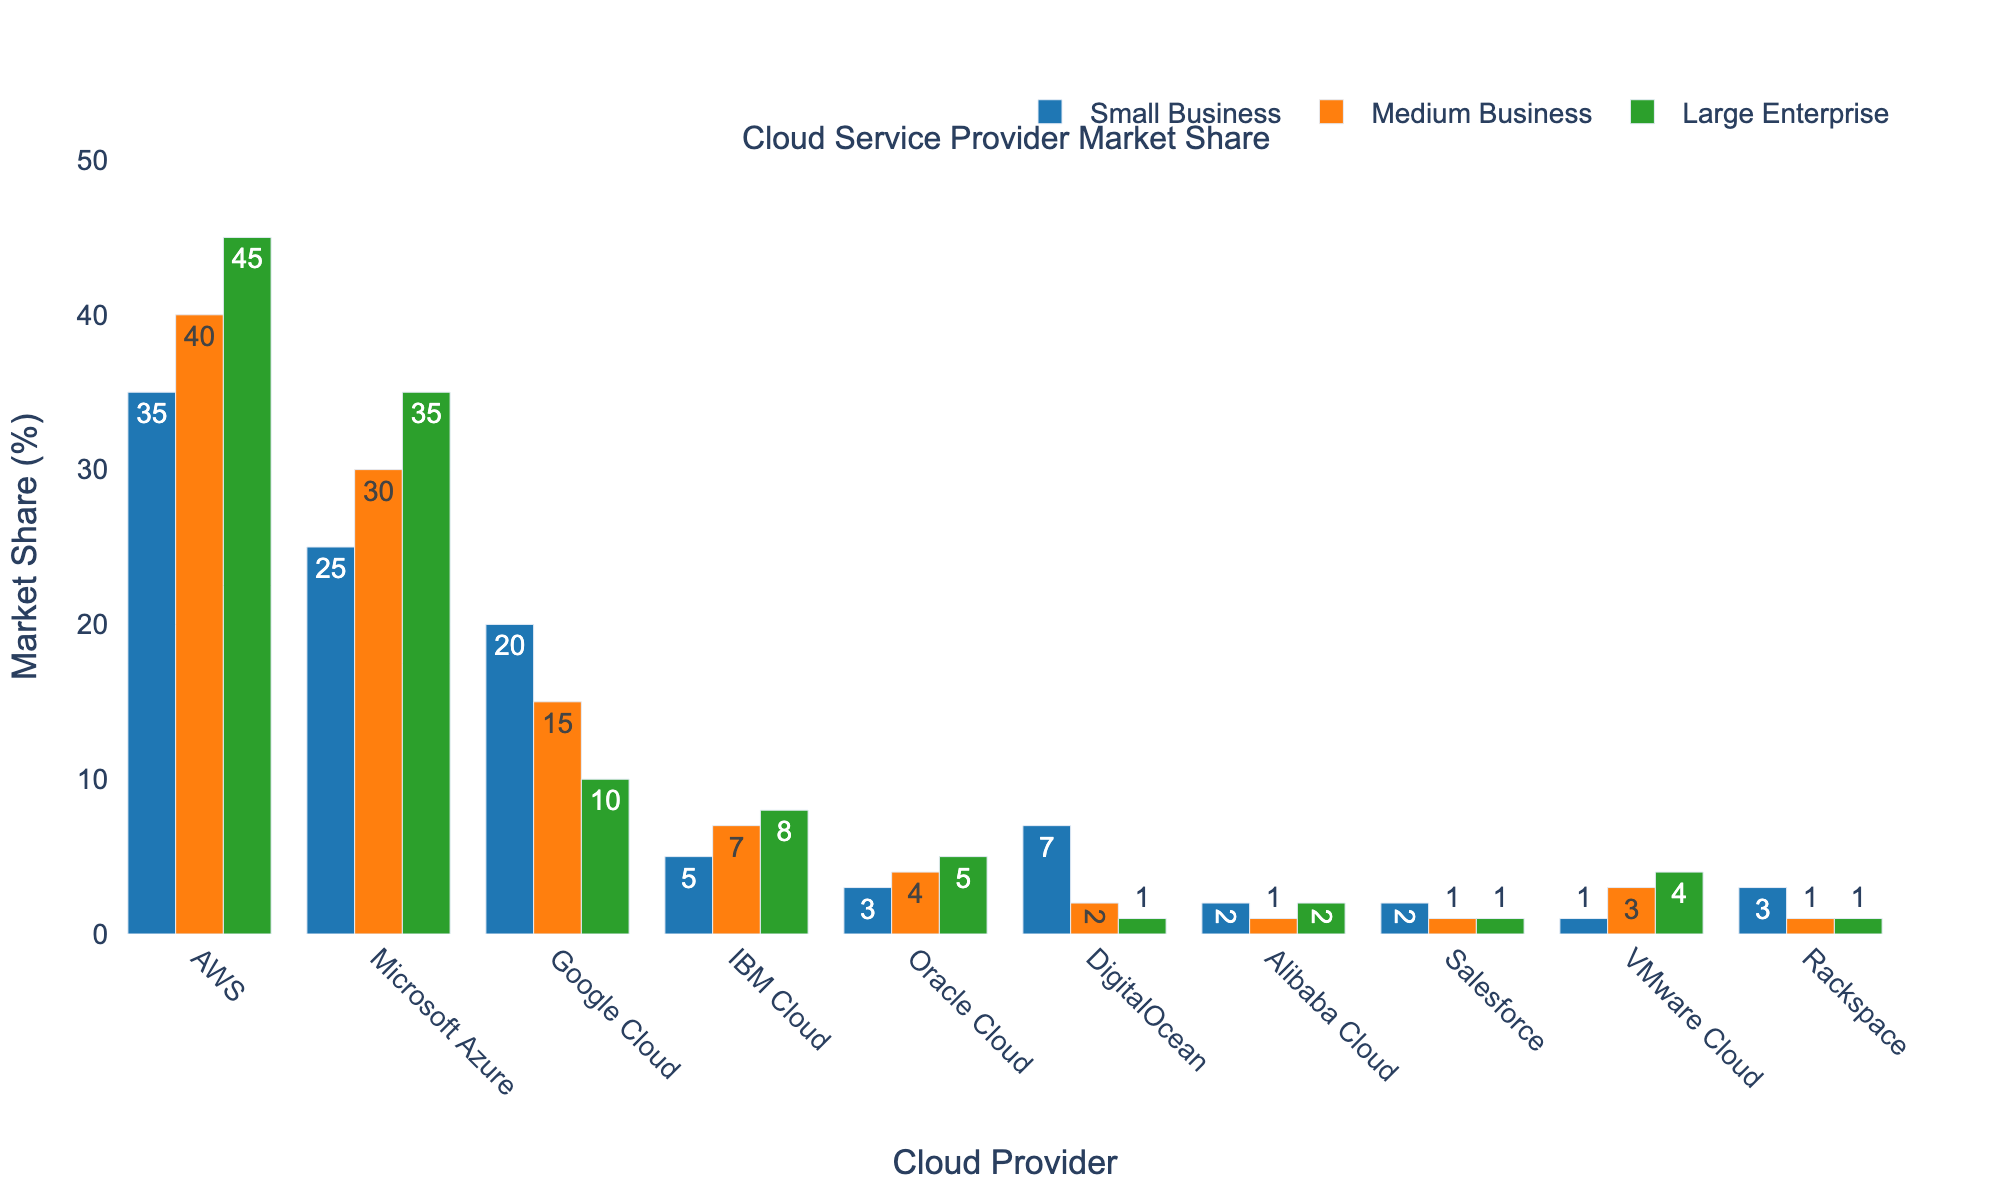Which cloud provider has the highest market share among medium businesses? Look at the Medium Business bars and see which one is the tallest. AWS has a market share of 40%, which is the highest among medium businesses.
Answer: AWS What is the total market share for IBM Cloud across all company sizes? Sum the market shares of IBM Cloud for Small Business, Medium Business, and Large Enterprise. IBM Cloud has 5% (Small Business) + 7% (Medium Business) + 8% (Large Enterprise) = 20%.
Answer: 20% Which company has the smallest market share for large enterprises? Examine the Large Enterprise bars to find the shortest one. Salesforce has the smallest market share at 1%.
Answer: Salesforce How much higher is AWS's market share in large enterprises compared to Google Cloud? Compare the market share percentages for AWS and Google Cloud in Large Enterprise. AWS has 45%, and Google Cloud has 10%. The difference is 45% - 10% = 35%.
Answer: 35% Is the market share of DigitalOcean for small businesses greater than its market share for medium and large enterprises combined? Compare DigitalOcean's market share for Small Business (7%) to the combined market share for Medium Business (2%) and Large Enterprise (1%). The combined share is 2% + 1% = 3%, which is less than 7%.
Answer: Yes Which cloud provider has a consistent market share distribution across different company sizes? Look for the cloud provider with similar heights of bars across Small, Medium, and Large Enterprises. AWS (35% Small, 40% Medium, 45% Large) demonstrates consistent market share across different company sizes.
Answer: AWS What is the average market share of Google Cloud across all company sizes? Calculate the average of Google Cloud's market shares: (20% Small Business + 15% Medium Business + 10% Large Enterprise) / 3 = 45% / 3 = 15%.
Answer: 15% Among the listed cloud providers, which one has the highest market share in small businesses other than AWS? Look at the Small Business bars excluding AWS. Microsoft Azure has the second highest market share at 25%.
Answer: Microsoft Azure 